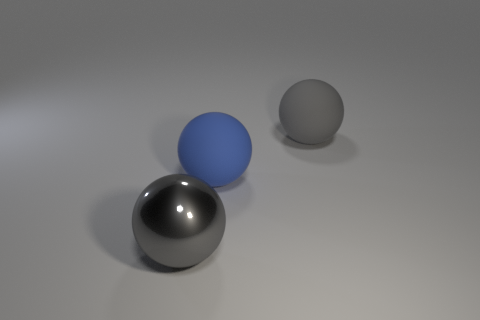There is a sphere that is both on the left side of the gray rubber object and behind the gray metallic sphere; what is its size?
Offer a very short reply. Large. The object that is in front of the gray matte object and right of the metal thing is what color?
Give a very brief answer. Blue. Is the number of gray objects that are left of the large gray metal sphere less than the number of large objects in front of the big gray matte thing?
Give a very brief answer. Yes. What number of blue objects have the same shape as the gray matte thing?
Provide a succinct answer. 1. There is another ball that is made of the same material as the blue sphere; what size is it?
Give a very brief answer. Large. What is the color of the large matte thing on the left side of the gray thing that is behind the large gray metal thing?
Your response must be concise. Blue. There is a big metal object; is its shape the same as the large gray thing that is right of the gray shiny object?
Offer a terse response. Yes. What number of gray rubber spheres have the same size as the blue rubber thing?
Make the answer very short. 1. There is a blue object that is the same shape as the gray shiny object; what material is it?
Give a very brief answer. Rubber. There is a big matte sphere that is behind the large blue rubber ball; does it have the same color as the metallic object on the left side of the gray rubber thing?
Provide a short and direct response. Yes. 